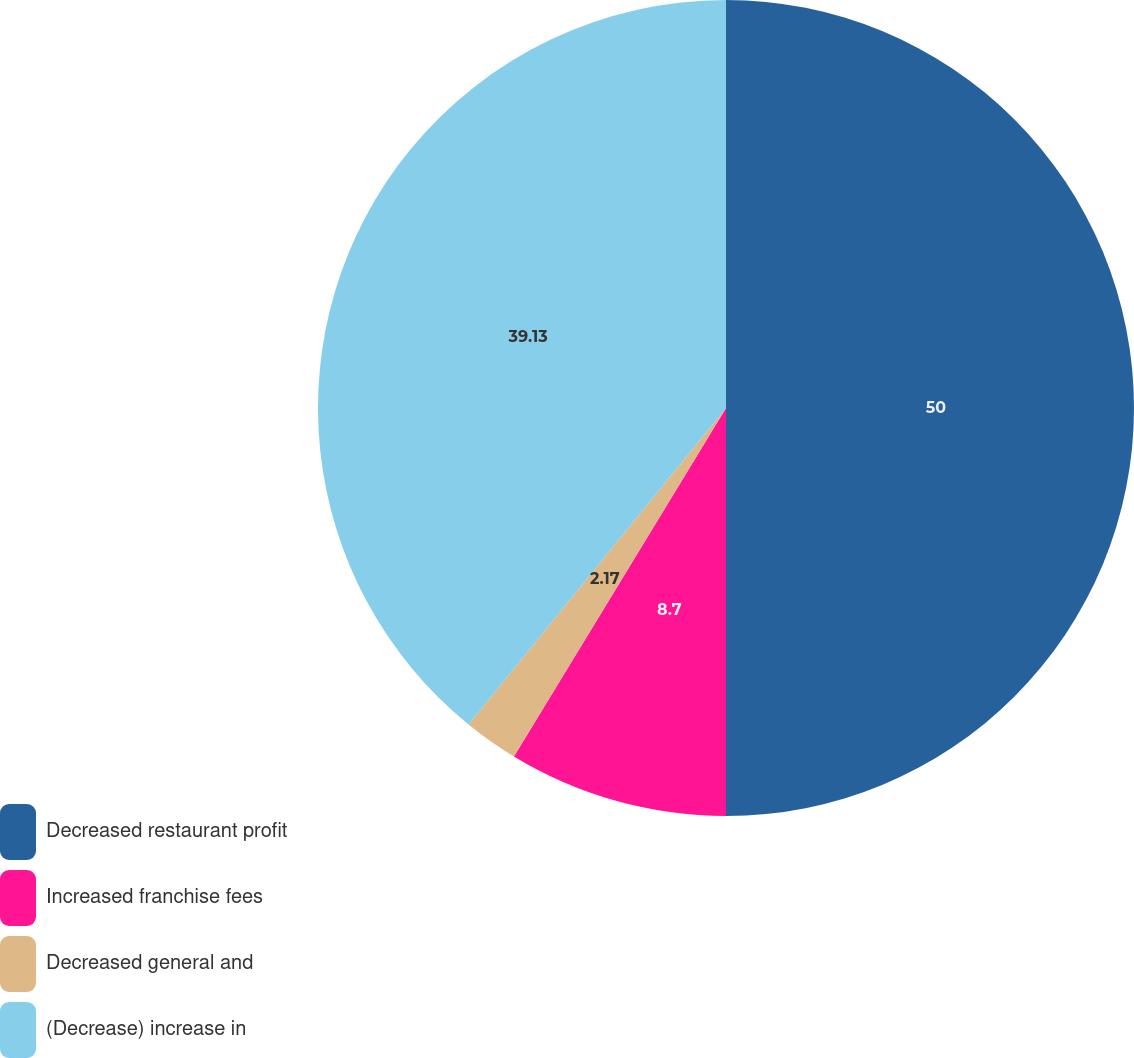Convert chart. <chart><loc_0><loc_0><loc_500><loc_500><pie_chart><fcel>Decreased restaurant profit<fcel>Increased franchise fees<fcel>Decreased general and<fcel>(Decrease) increase in<nl><fcel>50.0%<fcel>8.7%<fcel>2.17%<fcel>39.13%<nl></chart> 